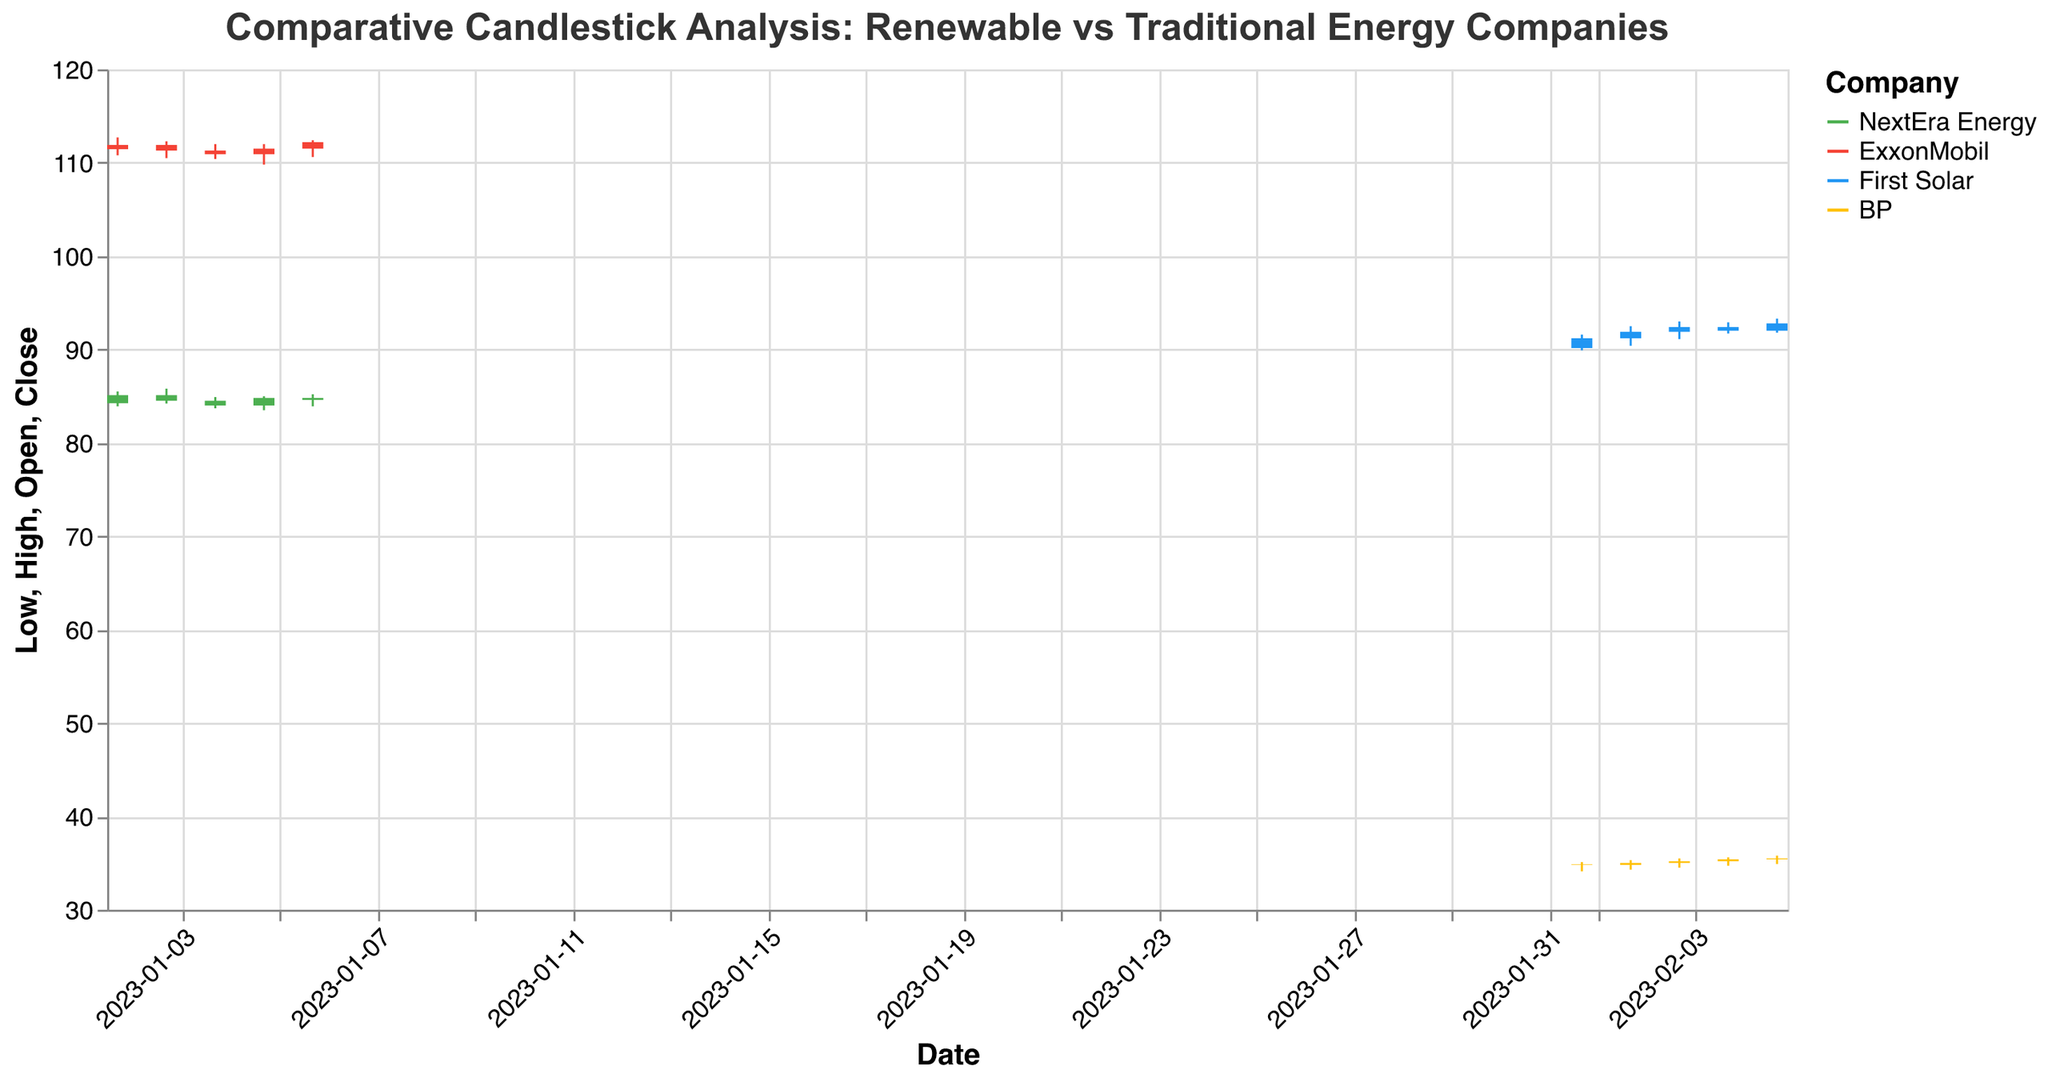What is the title of the figure? The title is located at the top of the figure and provides an overview of what the figure is about. The title of this figure is "Comparative Candlestick Analysis: Renewable vs Traditional Energy Companies".
Answer: Comparative Candlestick Analysis: Renewable vs Traditional Energy Companies What companies are compared in the figure? The figure compares four different companies, as indicated by the color legend on the right side of the plot. These companies are NextEra Energy, ExxonMobil, First Solar, and BP.
Answer: NextEra Energy, ExxonMobil, First Solar, BP Which company has the highest closing price on 2023-01-02? To find the highest closing price on 2023-01-02, locate the candlesticks for that date and compare the closing prices. ExxonMobil has the highest closing price at 111.90.
Answer: ExxonMobil What is the color used to represent First Solar in the figure? According to the legend on the right side of the plot, First Solar is represented by the color blue.
Answer: Blue On 2023-01-03, did NextEra Energy's closing price increase or decrease compared to the previous day? Check the candlestick for NextEra Energy on 2023-01-03 and compare the closing price to the previous day's closing price (2023-01-02). The closing price decreased from 85.10 to 84.50.
Answer: Decrease What is the range (difference between the high and low prices) for BP on 2023-02-03? For BP on 2023-02-03, locate the high and low prices from the corresponding candlestick. The high is 35.50 and the low is 34.50. The range is 35.50 - 34.50 = 1.00.
Answer: 1.00 Which company had the most trading volume on 2023-01-05? Identify the volume bars for each company on 2023-01-05. BP had the most trading volume with 4900000 shares.
Answer: BP How many days does the data cover for each company? The data covers five days for each company, as indicated by each company's candlesticks. Totaling 20 data points.
Answer: 5 days For which company was the closing price always higher than the opening price across all the given dates? Examine the candlesticks for each company. First Solar, represented by blue bars, had its closing prices always higher than its opening prices on all given dates.
Answer: First Solar Which traditional energy company had more price volatility (higher range) on 2023-01-03? Compare the ranges (difference between high and low prices) for ExxonMobil and BP on 2023-01-03. ExxonMobil has a range of 112.30 - 110.50 = 1.80, and BP has no data on January 3rd. Hence, ExxonMobil had higher volatility.
Answer: ExxonMobil 